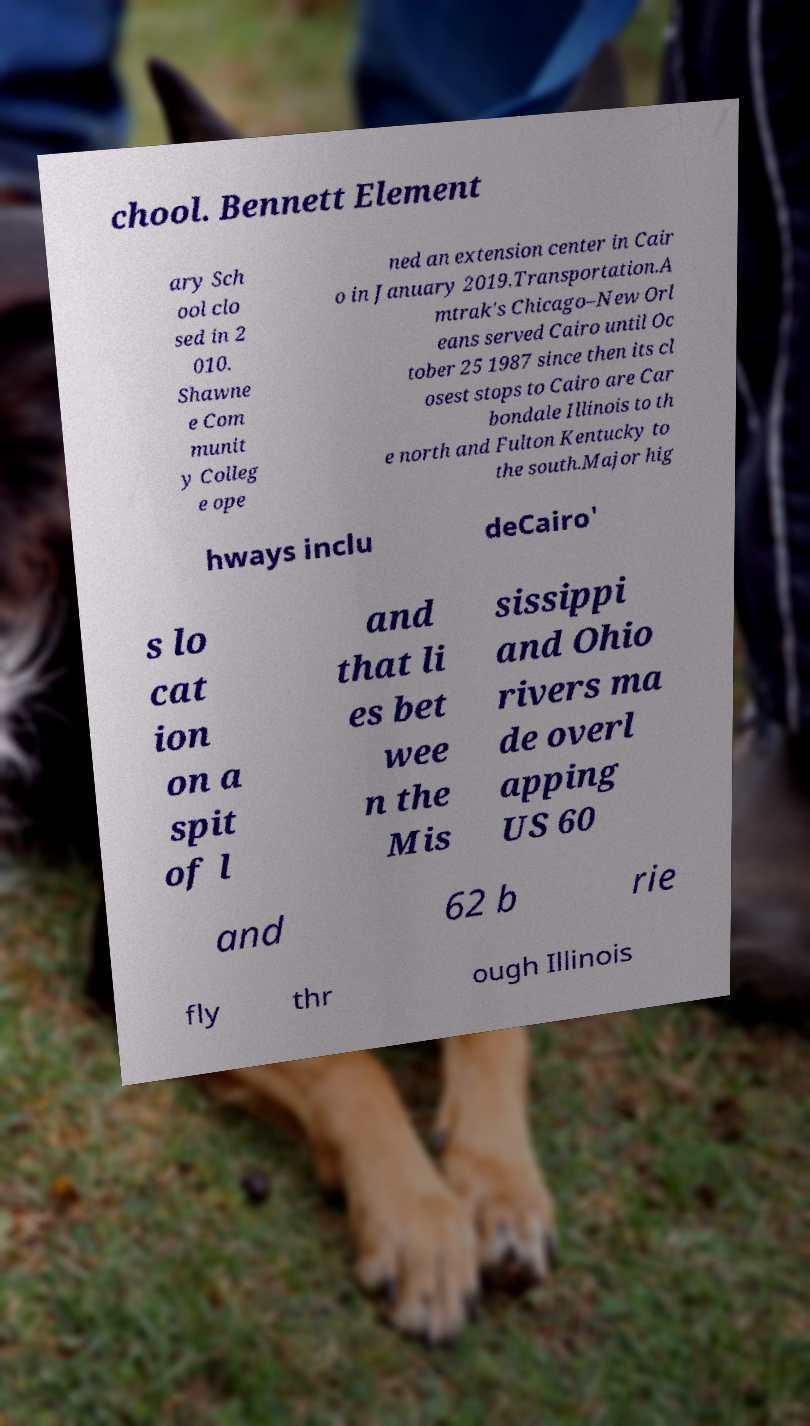Could you assist in decoding the text presented in this image and type it out clearly? chool. Bennett Element ary Sch ool clo sed in 2 010. Shawne e Com munit y Colleg e ope ned an extension center in Cair o in January 2019.Transportation.A mtrak's Chicago–New Orl eans served Cairo until Oc tober 25 1987 since then its cl osest stops to Cairo are Car bondale Illinois to th e north and Fulton Kentucky to the south.Major hig hways inclu deCairo' s lo cat ion on a spit of l and that li es bet wee n the Mis sissippi and Ohio rivers ma de overl apping US 60 and 62 b rie fly thr ough Illinois 